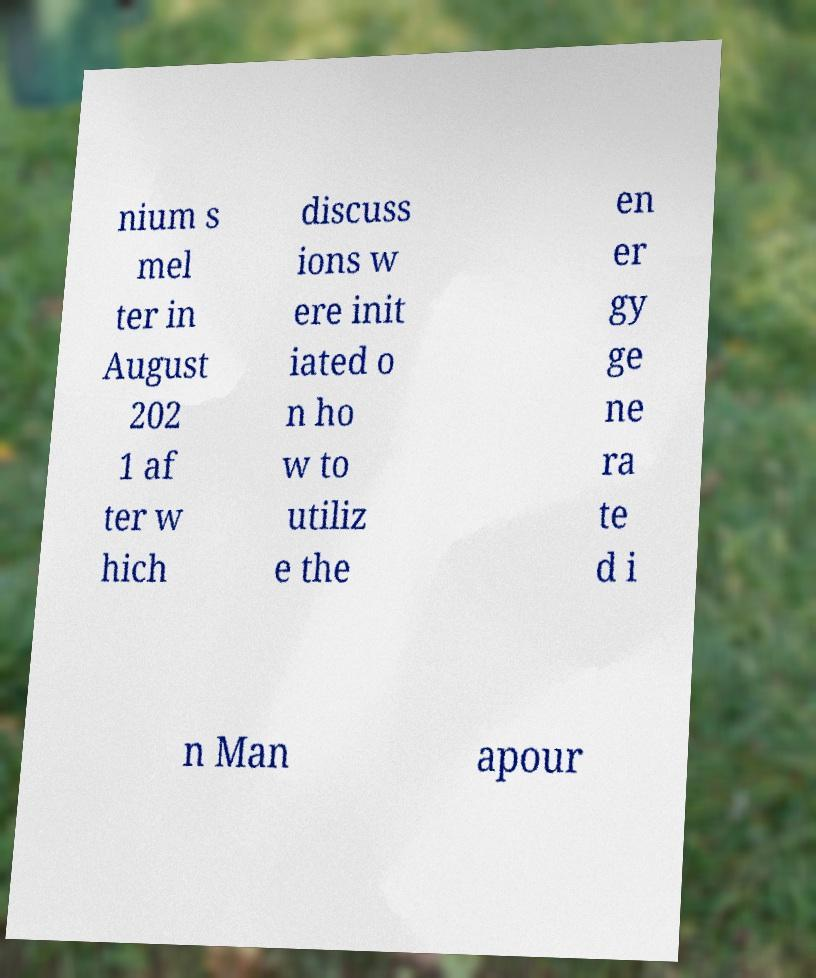I need the written content from this picture converted into text. Can you do that? nium s mel ter in August 202 1 af ter w hich discuss ions w ere init iated o n ho w to utiliz e the en er gy ge ne ra te d i n Man apour 